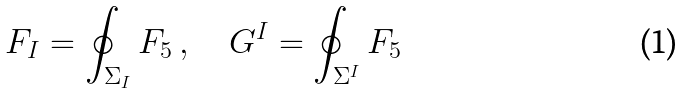Convert formula to latex. <formula><loc_0><loc_0><loc_500><loc_500>F _ { I } = \oint _ { \Sigma _ { I } } F _ { 5 } \, , \quad G ^ { I } = \oint _ { \Sigma ^ { I } } F _ { 5 } \,</formula> 